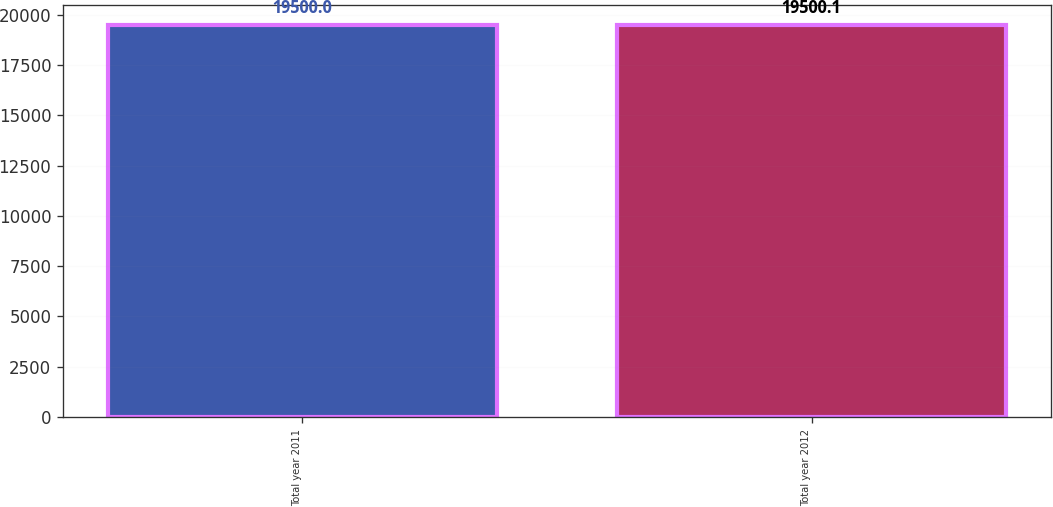Convert chart to OTSL. <chart><loc_0><loc_0><loc_500><loc_500><bar_chart><fcel>Total year 2011<fcel>Total year 2012<nl><fcel>19500<fcel>19500.1<nl></chart> 